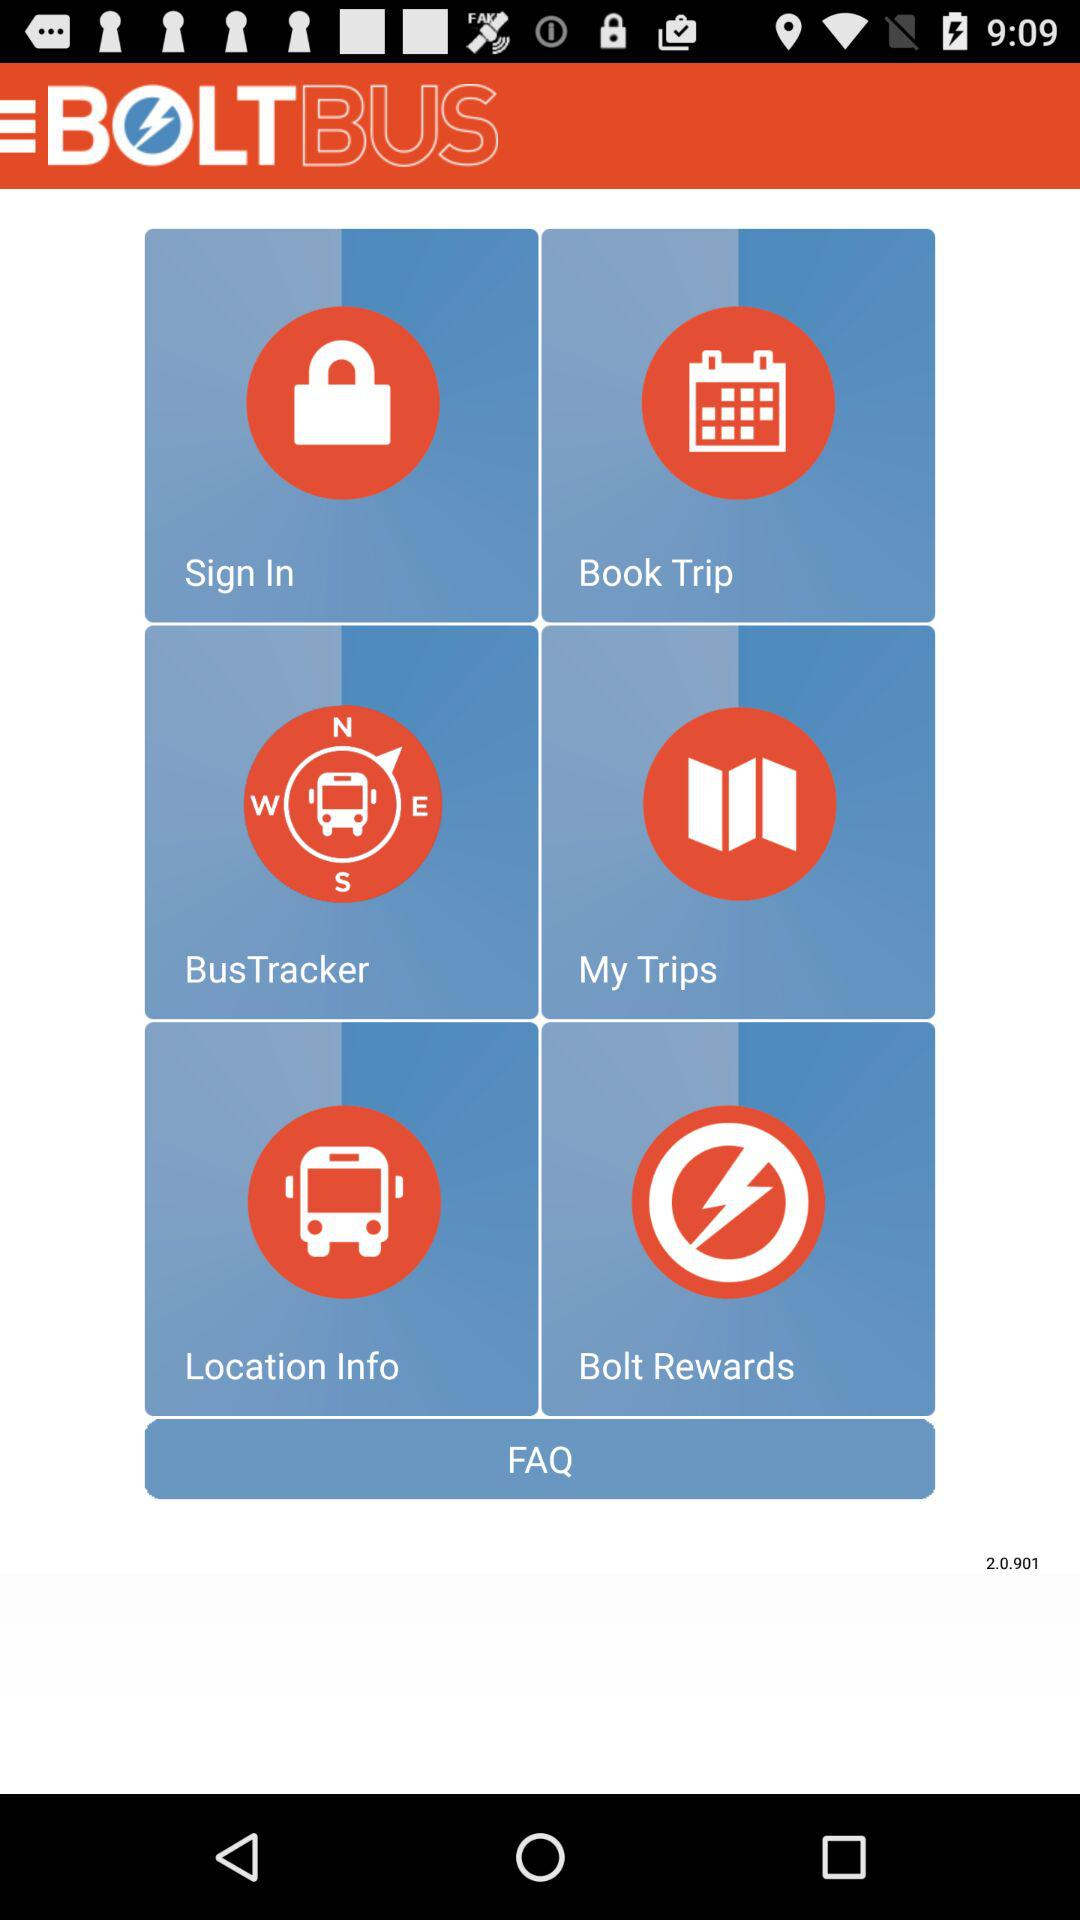Which version is used? The used version is 2.0.901. 